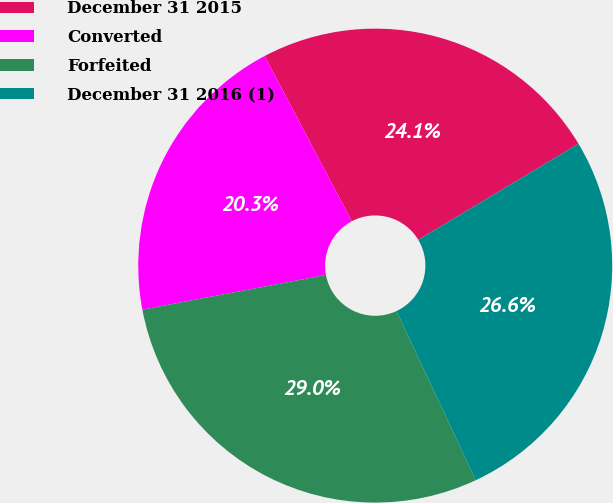Convert chart to OTSL. <chart><loc_0><loc_0><loc_500><loc_500><pie_chart><fcel>December 31 2015<fcel>Converted<fcel>Forfeited<fcel>December 31 2016 (1)<nl><fcel>24.13%<fcel>20.25%<fcel>28.99%<fcel>26.62%<nl></chart> 